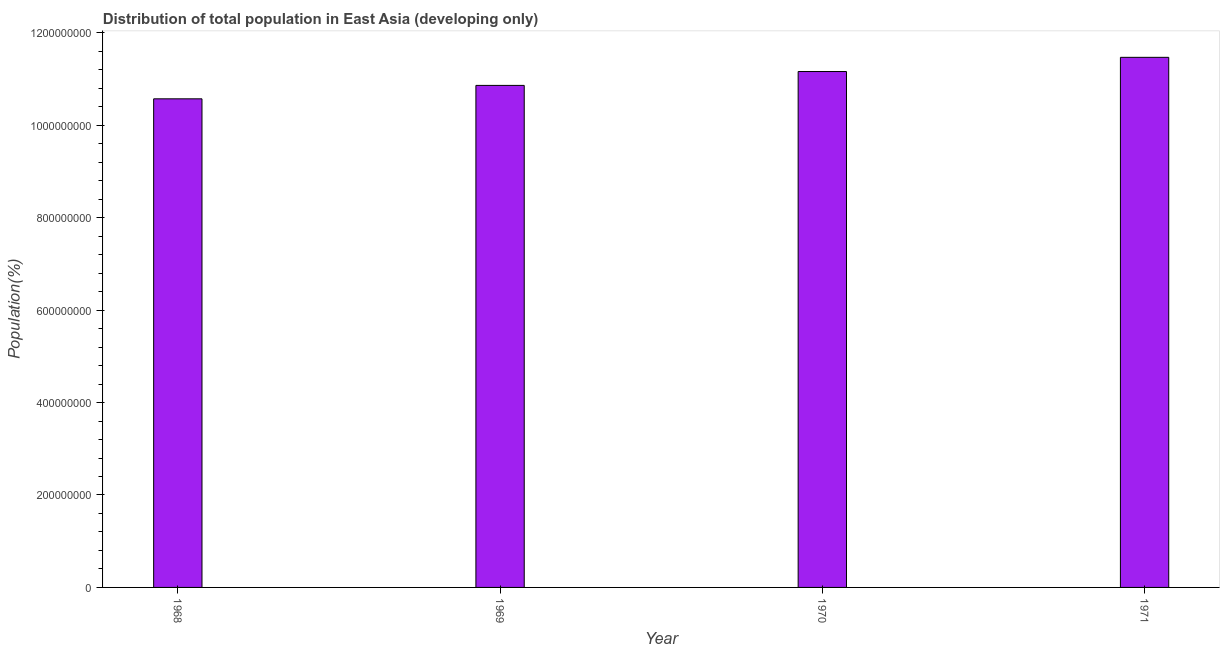Does the graph contain any zero values?
Give a very brief answer. No. What is the title of the graph?
Your answer should be compact. Distribution of total population in East Asia (developing only) . What is the label or title of the X-axis?
Make the answer very short. Year. What is the label or title of the Y-axis?
Offer a terse response. Population(%). What is the population in 1969?
Your answer should be compact. 1.09e+09. Across all years, what is the maximum population?
Give a very brief answer. 1.15e+09. Across all years, what is the minimum population?
Provide a short and direct response. 1.06e+09. In which year was the population maximum?
Offer a very short reply. 1971. In which year was the population minimum?
Provide a succinct answer. 1968. What is the sum of the population?
Your answer should be very brief. 4.41e+09. What is the difference between the population in 1968 and 1970?
Give a very brief answer. -5.91e+07. What is the average population per year?
Ensure brevity in your answer.  1.10e+09. What is the median population?
Offer a terse response. 1.10e+09. What is the ratio of the population in 1968 to that in 1971?
Your response must be concise. 0.92. Is the difference between the population in 1969 and 1970 greater than the difference between any two years?
Keep it short and to the point. No. What is the difference between the highest and the second highest population?
Offer a terse response. 3.07e+07. What is the difference between the highest and the lowest population?
Make the answer very short. 8.98e+07. How many bars are there?
Give a very brief answer. 4. What is the difference between two consecutive major ticks on the Y-axis?
Give a very brief answer. 2.00e+08. What is the Population(%) in 1968?
Your response must be concise. 1.06e+09. What is the Population(%) of 1969?
Offer a terse response. 1.09e+09. What is the Population(%) in 1970?
Your response must be concise. 1.12e+09. What is the Population(%) of 1971?
Your answer should be compact. 1.15e+09. What is the difference between the Population(%) in 1968 and 1969?
Provide a short and direct response. -2.91e+07. What is the difference between the Population(%) in 1968 and 1970?
Make the answer very short. -5.91e+07. What is the difference between the Population(%) in 1968 and 1971?
Offer a terse response. -8.98e+07. What is the difference between the Population(%) in 1969 and 1970?
Your answer should be very brief. -3.00e+07. What is the difference between the Population(%) in 1969 and 1971?
Offer a very short reply. -6.07e+07. What is the difference between the Population(%) in 1970 and 1971?
Provide a short and direct response. -3.07e+07. What is the ratio of the Population(%) in 1968 to that in 1969?
Ensure brevity in your answer.  0.97. What is the ratio of the Population(%) in 1968 to that in 1970?
Offer a very short reply. 0.95. What is the ratio of the Population(%) in 1968 to that in 1971?
Provide a succinct answer. 0.92. What is the ratio of the Population(%) in 1969 to that in 1970?
Your answer should be compact. 0.97. What is the ratio of the Population(%) in 1969 to that in 1971?
Your response must be concise. 0.95. What is the ratio of the Population(%) in 1970 to that in 1971?
Provide a succinct answer. 0.97. 